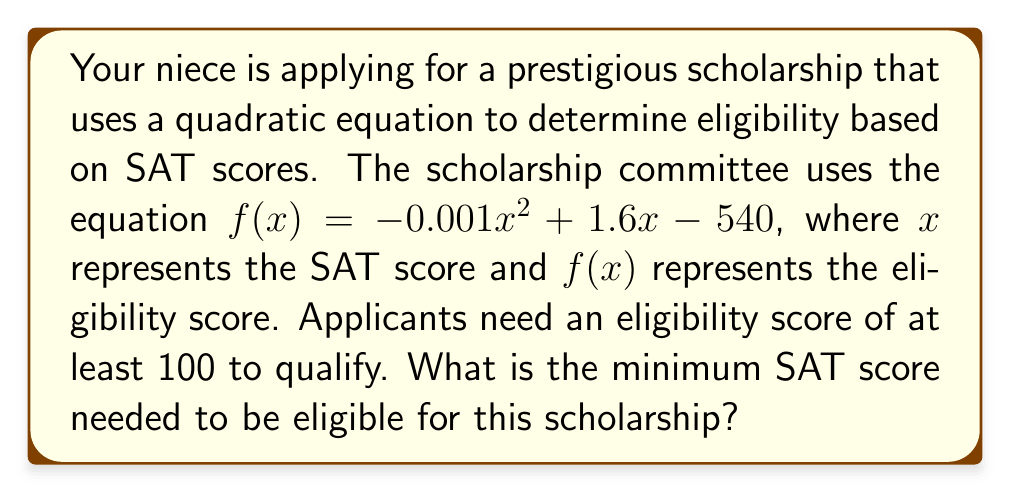Provide a solution to this math problem. Let's approach this step-by-step:

1) We need to find the value of $x$ where $f(x) = 100$. This gives us the equation:

   $-0.001x^2 + 1.6x - 540 = 100$

2) Rearrange the equation to standard form:

   $-0.001x^2 + 1.6x - 640 = 0$

3) Multiply all terms by -1000 to eliminate decimals:

   $x^2 - 1600x + 640000 = 0$

4) This is a quadratic equation in the form $ax^2 + bx + c = 0$, where:
   $a = 1$, $b = -1600$, and $c = 640000$

5) We can solve this using the quadratic formula: $x = \frac{-b \pm \sqrt{b^2 - 4ac}}{2a}$

6) Substituting our values:

   $x = \frac{1600 \pm \sqrt{(-1600)^2 - 4(1)(640000)}}{2(1)}$

7) Simplify:

   $x = \frac{1600 \pm \sqrt{2560000 - 2560000}}{2} = \frac{1600 \pm 0}{2} = 800$

8) Since we're looking for the minimum SAT score, we only need the lower solution.
Answer: The minimum SAT score needed to be eligible for the scholarship is 800. 